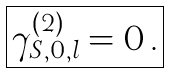<formula> <loc_0><loc_0><loc_500><loc_500>\boxed { \gamma _ { S , 0 , l } ^ { ( 2 ) } = 0 \, . }</formula> 